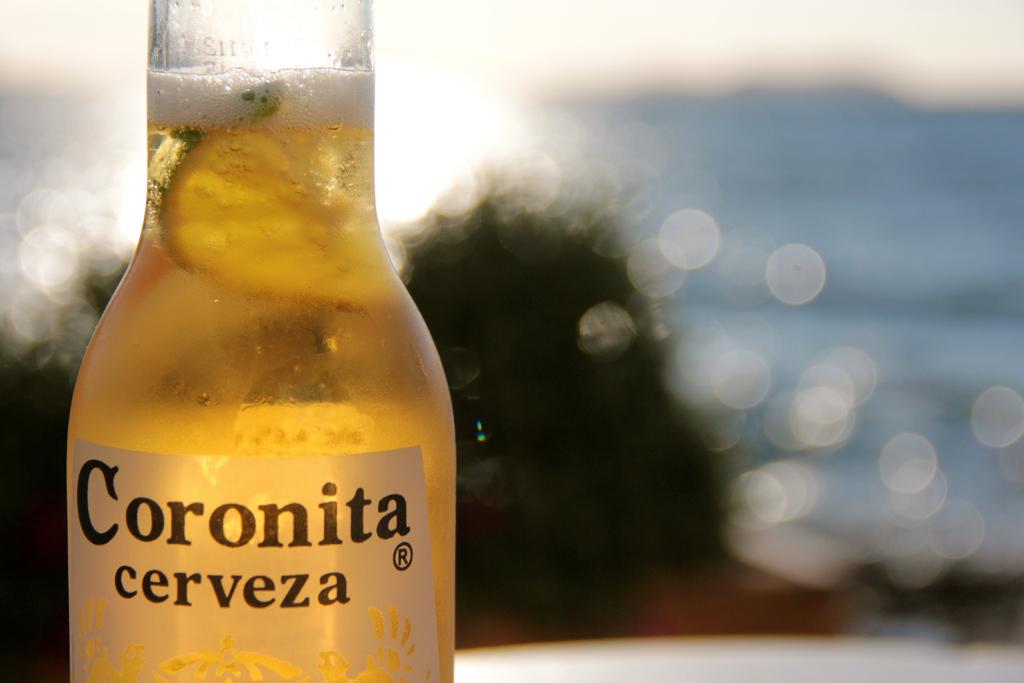What is in the bottle?
Offer a terse response. Coronita cerveza. 